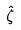Convert formula to latex. <formula><loc_0><loc_0><loc_500><loc_500>\hat { \zeta }</formula> 